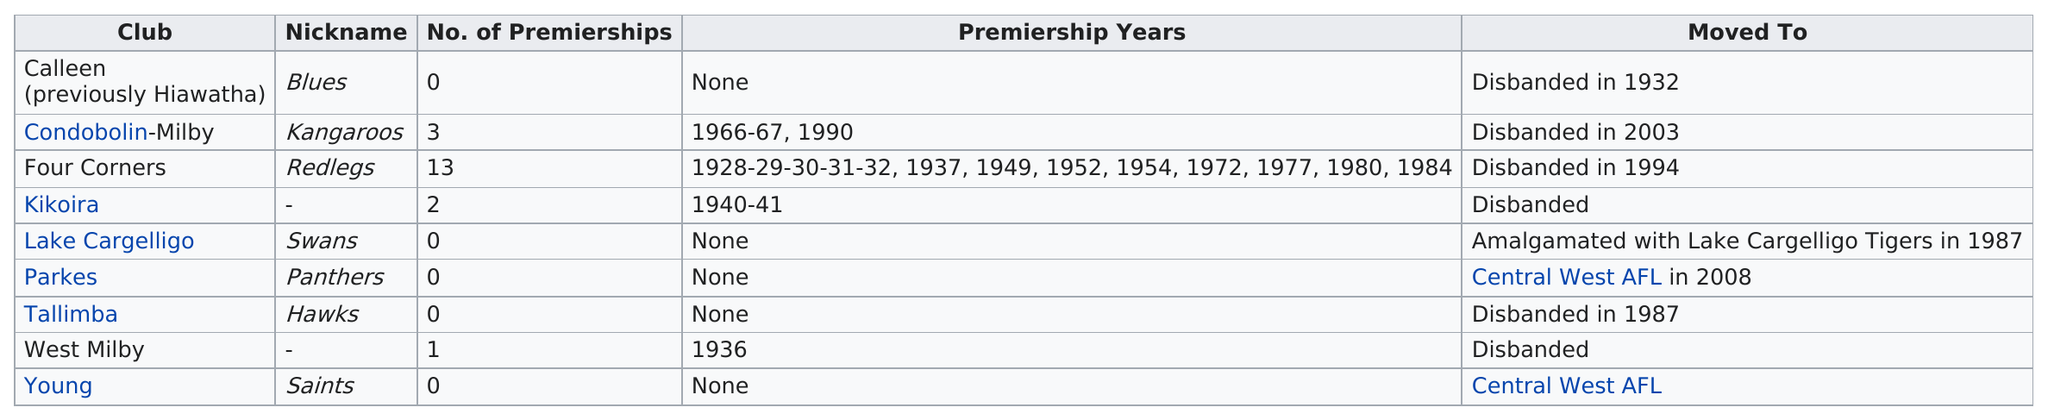Mention a couple of crucial points in this snapshot. According to the information provided, Four Corners has won 13 premierships. Furthermore, the team was known as the Redlegs. In 1972, Four Corners was the top club. Four Corners has more premierships than West Milby. The nickname 'Redlegs' was assigned to the Kangaroos team. Two clubs, Kikoira and West Milby, have no nickname listed. 